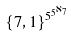Convert formula to latex. <formula><loc_0><loc_0><loc_500><loc_500>\{ 7 , 1 \} ^ { 5 ^ { 5 ^ { \aleph _ { 7 } } } }</formula> 